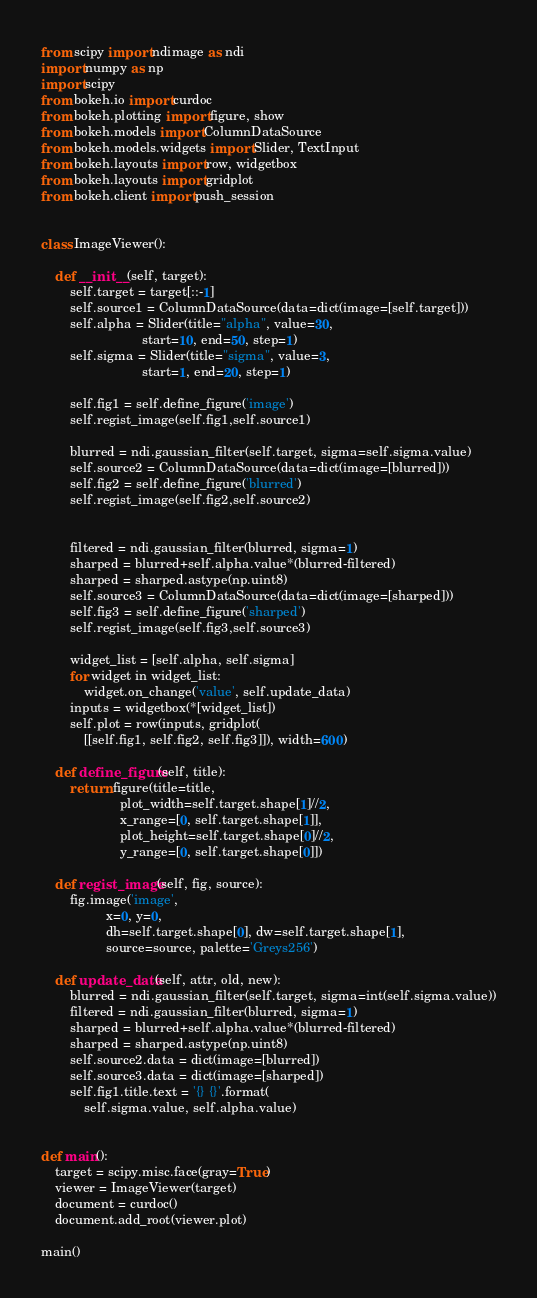<code> <loc_0><loc_0><loc_500><loc_500><_Python_>from scipy import ndimage as ndi
import numpy as np
import scipy
from bokeh.io import curdoc
from bokeh.plotting import figure, show
from bokeh.models import ColumnDataSource
from bokeh.models.widgets import Slider, TextInput
from bokeh.layouts import row, widgetbox
from bokeh.layouts import gridplot
from bokeh.client import push_session


class ImageViewer():

    def __init__(self, target):
        self.target = target[::-1]
        self.source1 = ColumnDataSource(data=dict(image=[self.target]))
        self.alpha = Slider(title="alpha", value=30,
                            start=10, end=50, step=1)
        self.sigma = Slider(title="sigma", value=3,
                            start=1, end=20, step=1)

        self.fig1 = self.define_figure('image')
        self.regist_image(self.fig1,self.source1)

        blurred = ndi.gaussian_filter(self.target, sigma=self.sigma.value)
        self.source2 = ColumnDataSource(data=dict(image=[blurred]))
        self.fig2 = self.define_figure('blurred')
        self.regist_image(self.fig2,self.source2)


        filtered = ndi.gaussian_filter(blurred, sigma=1)
        sharped = blurred+self.alpha.value*(blurred-filtered)
        sharped = sharped.astype(np.uint8)
        self.source3 = ColumnDataSource(data=dict(image=[sharped]))
        self.fig3 = self.define_figure('sharped')
        self.regist_image(self.fig3,self.source3)

        widget_list = [self.alpha, self.sigma]
        for widget in widget_list:
            widget.on_change('value', self.update_data)
        inputs = widgetbox(*[widget_list])
        self.plot = row(inputs, gridplot(
            [[self.fig1, self.fig2, self.fig3]]), width=600)

    def define_figure(self, title):
        return figure(title=title,
                      plot_width=self.target.shape[1]//2,
                      x_range=[0, self.target.shape[1]],
                      plot_height=self.target.shape[0]//2,
                      y_range=[0, self.target.shape[0]])

    def regist_image(self, fig, source):
        fig.image('image',
                  x=0, y=0,
                  dh=self.target.shape[0], dw=self.target.shape[1],
                  source=source, palette='Greys256')

    def update_data(self, attr, old, new):
        blurred = ndi.gaussian_filter(self.target, sigma=int(self.sigma.value))
        filtered = ndi.gaussian_filter(blurred, sigma=1)
        sharped = blurred+self.alpha.value*(blurred-filtered)
        sharped = sharped.astype(np.uint8)
        self.source2.data = dict(image=[blurred])
        self.source3.data = dict(image=[sharped])
        self.fig1.title.text = '{} {}'.format(
            self.sigma.value, self.alpha.value)


def main():
    target = scipy.misc.face(gray=True)
    viewer = ImageViewer(target)
    document = curdoc()
    document.add_root(viewer.plot)

main()
</code> 